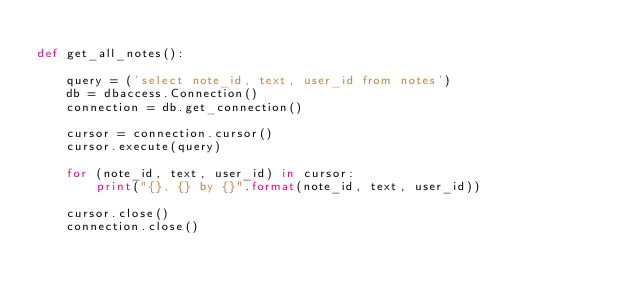Convert code to text. <code><loc_0><loc_0><loc_500><loc_500><_Python_>
def get_all_notes():

    query = ('select note_id, text, user_id from notes')
    db = dbaccess.Connection()
    connection = db.get_connection()
    
    cursor = connection.cursor()
    cursor.execute(query)

    for (note_id, text, user_id) in cursor:
        print("{}, {} by {}".format(note_id, text, user_id))

    cursor.close()
    connection.close()

</code> 